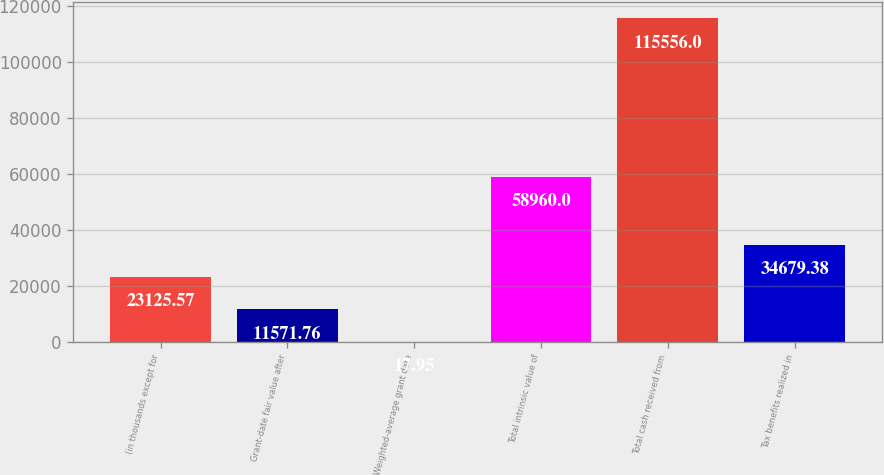Convert chart to OTSL. <chart><loc_0><loc_0><loc_500><loc_500><bar_chart><fcel>(in thousands except for<fcel>Grant-date fair value after<fcel>Weighted-average grant date<fcel>Total intrinsic value of<fcel>Total cash received from<fcel>Tax benefits realized in<nl><fcel>23125.6<fcel>11571.8<fcel>17.95<fcel>58960<fcel>115556<fcel>34679.4<nl></chart> 